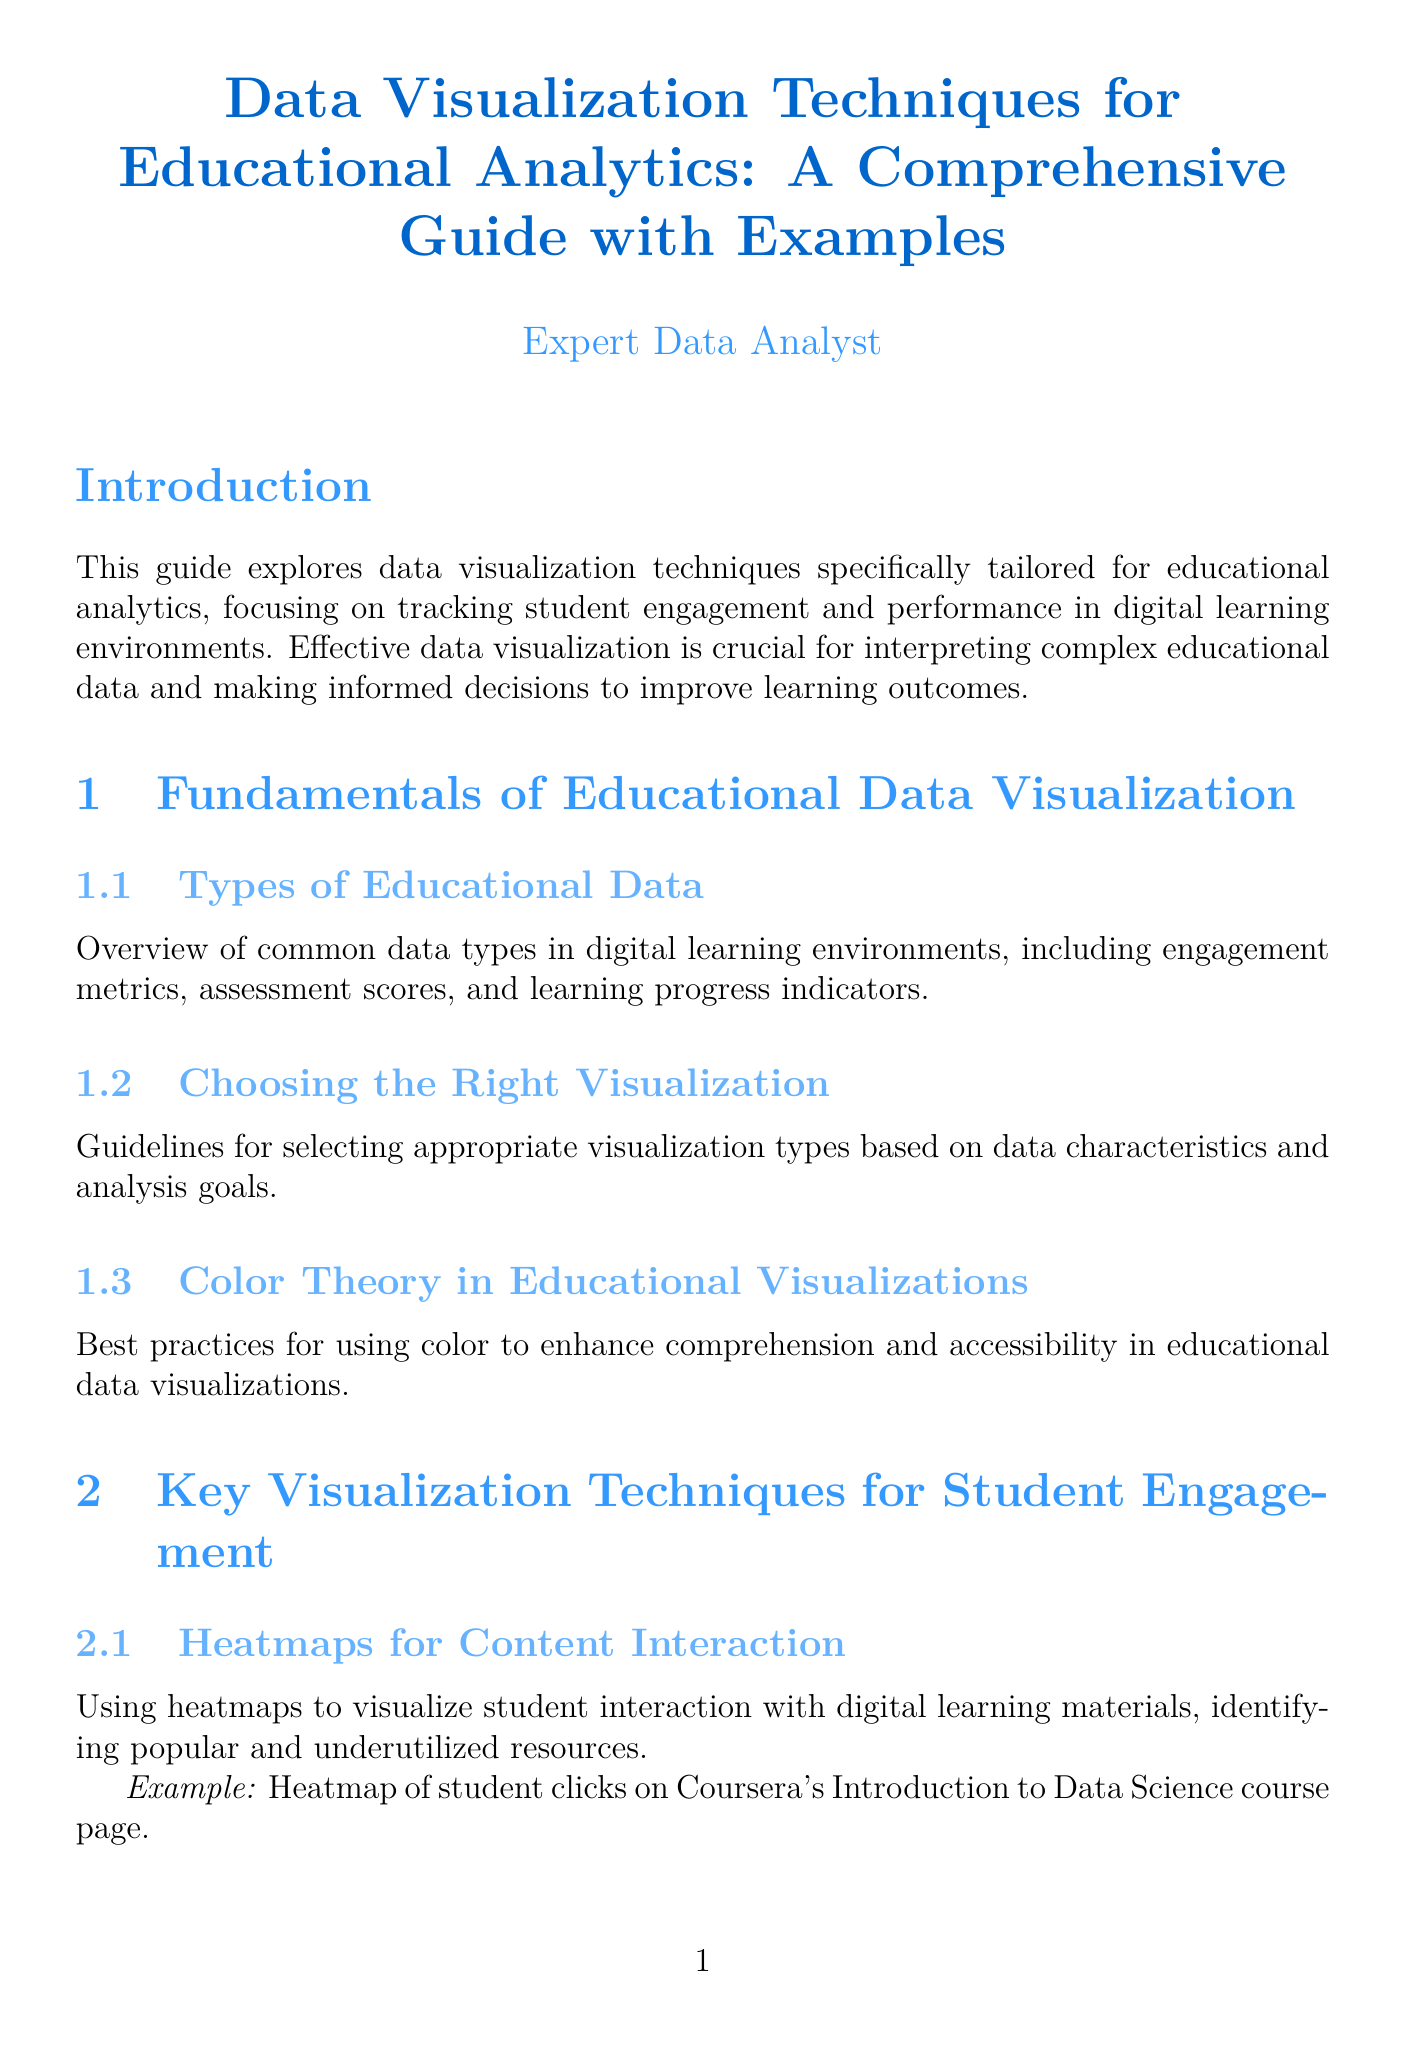What is the title of the document? The title of the document is clearly stated at the beginning.
Answer: Data Visualization Techniques for Educational Analytics: A Comprehensive Guide with Examples How many chapters are in the document? The number of chapters is explicitly listed in the table of contents.
Answer: Five What is the focus of this guide? The introduction outlines the main focus of the guide regarding educational analytics.
Answer: Tracking student engagement and performance What visualization technique uses color to enhance comprehension? The section on color theory discusses this visualization technique.
Answer: Color Theory in Educational Visualizations Which tool is mentioned for interactive dashboards? The section on tools and technologies specifies a tool suitable for creating interactive dashboards.
Answer: Tableau What type of chart is used to analyze engagement patterns over time? The section on engagement patterns specifies the type of chart used.
Answer: Time Series Charts What is a key ethical consideration when visualizing educational data? Best practices for ethical considerations are discussed in the document.
Answer: Ensuring Data Privacy and Security Which programming libraries are introduced for custom visualizations? The section on programming libraries lists some examples provided in the document.
Answer: Matplotlib, Seaborn, Plotly What type of visualization helps track user navigation paths? The document specifies this type of visualization in the student engagement techniques section.
Answer: Sankey Diagrams for User Flow Analysis 